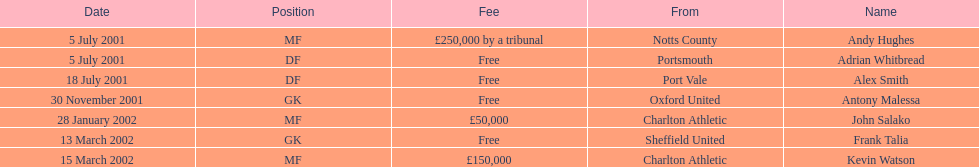Are at least 2 different nationalities represented on the chart? Yes. 